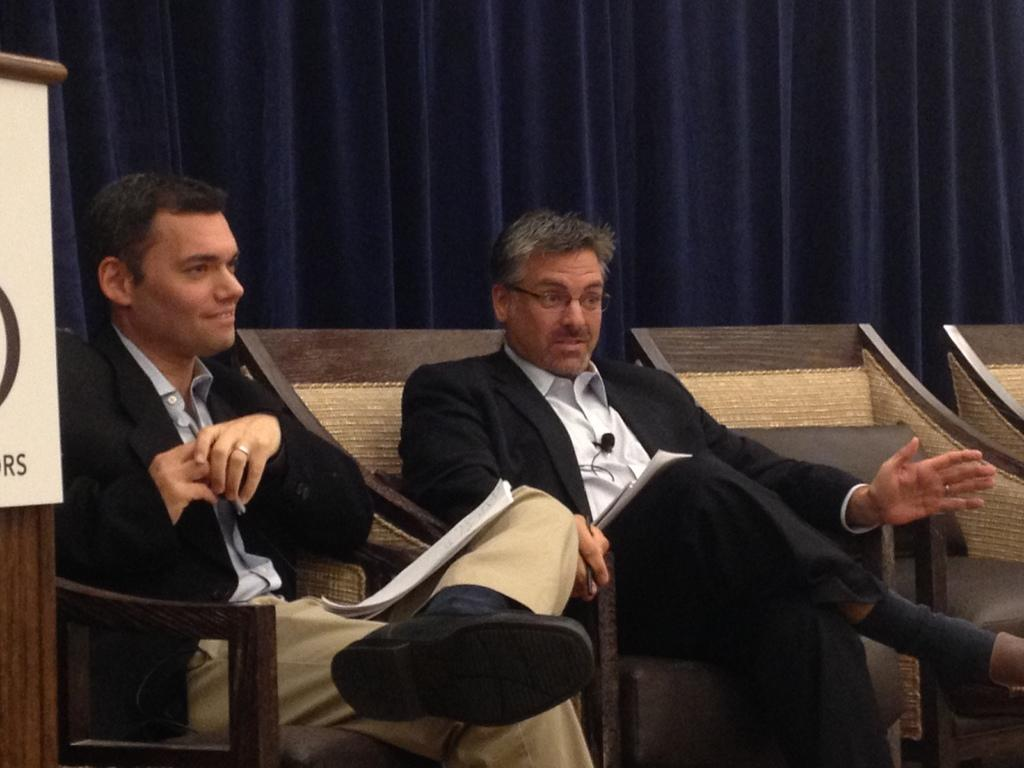How many people are in the image? There are two men in the image. What are the men doing in the image? The men are sitting on chairs. What can be seen in the background of the image? There is a blue curtain in the background of the image. What type of baseball error can be seen in the image? There is no baseball or any reference to a baseball game in the image, so it is not possible to determine if there is any baseball error present. 